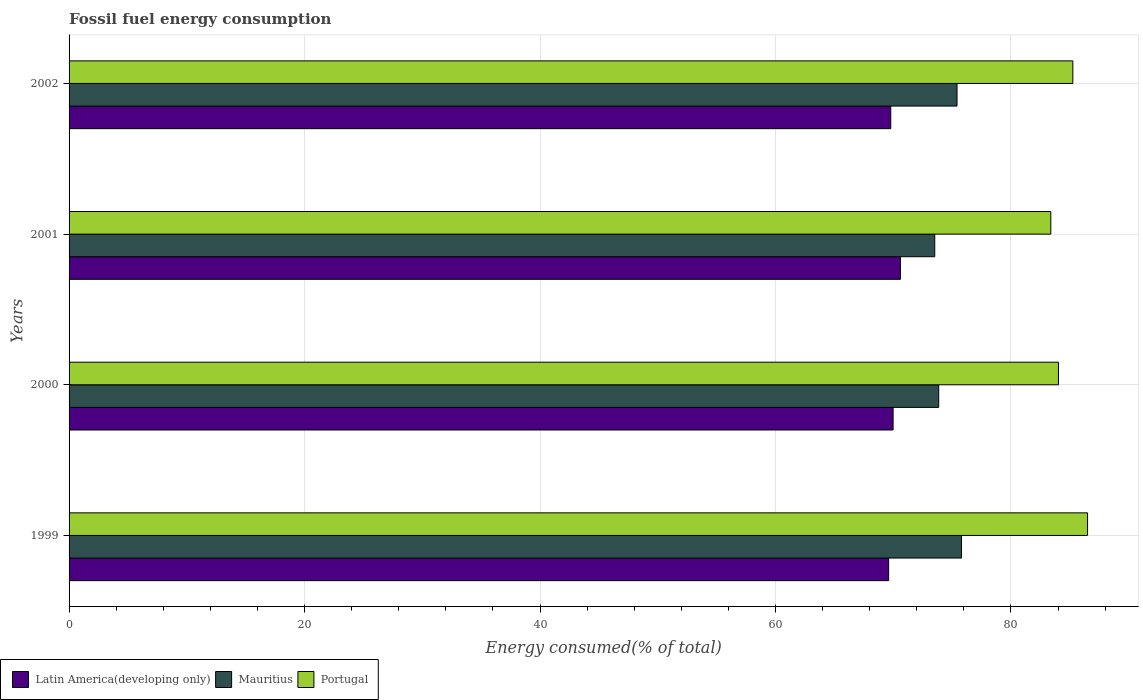How many groups of bars are there?
Your answer should be very brief. 4. Are the number of bars per tick equal to the number of legend labels?
Your response must be concise. Yes. Are the number of bars on each tick of the Y-axis equal?
Offer a very short reply. Yes. What is the label of the 3rd group of bars from the top?
Ensure brevity in your answer.  2000. What is the percentage of energy consumed in Portugal in 2000?
Provide a succinct answer. 84.04. Across all years, what is the maximum percentage of energy consumed in Latin America(developing only)?
Offer a terse response. 70.61. Across all years, what is the minimum percentage of energy consumed in Portugal?
Give a very brief answer. 83.39. What is the total percentage of energy consumed in Portugal in the graph?
Your answer should be very brief. 339.19. What is the difference between the percentage of energy consumed in Portugal in 1999 and that in 2000?
Offer a very short reply. 2.47. What is the difference between the percentage of energy consumed in Latin America(developing only) in 1999 and the percentage of energy consumed in Portugal in 2001?
Offer a very short reply. -13.77. What is the average percentage of energy consumed in Latin America(developing only) per year?
Your answer should be compact. 70. In the year 1999, what is the difference between the percentage of energy consumed in Latin America(developing only) and percentage of energy consumed in Mauritius?
Keep it short and to the point. -6.19. What is the ratio of the percentage of energy consumed in Latin America(developing only) in 2000 to that in 2002?
Provide a succinct answer. 1. Is the percentage of energy consumed in Mauritius in 2001 less than that in 2002?
Keep it short and to the point. Yes. Is the difference between the percentage of energy consumed in Latin America(developing only) in 1999 and 2002 greater than the difference between the percentage of energy consumed in Mauritius in 1999 and 2002?
Make the answer very short. No. What is the difference between the highest and the second highest percentage of energy consumed in Mauritius?
Keep it short and to the point. 0.38. What is the difference between the highest and the lowest percentage of energy consumed in Portugal?
Offer a very short reply. 3.12. Is the sum of the percentage of energy consumed in Mauritius in 1999 and 2001 greater than the maximum percentage of energy consumed in Latin America(developing only) across all years?
Offer a very short reply. Yes. What does the 1st bar from the bottom in 1999 represents?
Your answer should be compact. Latin America(developing only). How many bars are there?
Offer a very short reply. 12. Are all the bars in the graph horizontal?
Offer a very short reply. Yes. How many years are there in the graph?
Provide a succinct answer. 4. Does the graph contain any zero values?
Give a very brief answer. No. Does the graph contain grids?
Your answer should be very brief. Yes. Where does the legend appear in the graph?
Make the answer very short. Bottom left. How are the legend labels stacked?
Ensure brevity in your answer.  Horizontal. What is the title of the graph?
Provide a succinct answer. Fossil fuel energy consumption. Does "Singapore" appear as one of the legend labels in the graph?
Offer a very short reply. No. What is the label or title of the X-axis?
Ensure brevity in your answer.  Energy consumed(% of total). What is the Energy consumed(% of total) of Latin America(developing only) in 1999?
Offer a terse response. 69.61. What is the Energy consumed(% of total) of Mauritius in 1999?
Your answer should be very brief. 75.8. What is the Energy consumed(% of total) of Portugal in 1999?
Make the answer very short. 86.51. What is the Energy consumed(% of total) in Latin America(developing only) in 2000?
Ensure brevity in your answer.  69.99. What is the Energy consumed(% of total) in Mauritius in 2000?
Ensure brevity in your answer.  73.86. What is the Energy consumed(% of total) in Portugal in 2000?
Ensure brevity in your answer.  84.04. What is the Energy consumed(% of total) in Latin America(developing only) in 2001?
Give a very brief answer. 70.61. What is the Energy consumed(% of total) of Mauritius in 2001?
Your answer should be compact. 73.53. What is the Energy consumed(% of total) in Portugal in 2001?
Provide a succinct answer. 83.39. What is the Energy consumed(% of total) in Latin America(developing only) in 2002?
Make the answer very short. 69.79. What is the Energy consumed(% of total) in Mauritius in 2002?
Your answer should be very brief. 75.42. What is the Energy consumed(% of total) in Portugal in 2002?
Make the answer very short. 85.26. Across all years, what is the maximum Energy consumed(% of total) in Latin America(developing only)?
Keep it short and to the point. 70.61. Across all years, what is the maximum Energy consumed(% of total) in Mauritius?
Make the answer very short. 75.8. Across all years, what is the maximum Energy consumed(% of total) in Portugal?
Your answer should be compact. 86.51. Across all years, what is the minimum Energy consumed(% of total) in Latin America(developing only)?
Ensure brevity in your answer.  69.61. Across all years, what is the minimum Energy consumed(% of total) in Mauritius?
Provide a succinct answer. 73.53. Across all years, what is the minimum Energy consumed(% of total) in Portugal?
Your answer should be compact. 83.39. What is the total Energy consumed(% of total) of Latin America(developing only) in the graph?
Offer a terse response. 280. What is the total Energy consumed(% of total) in Mauritius in the graph?
Give a very brief answer. 298.61. What is the total Energy consumed(% of total) of Portugal in the graph?
Give a very brief answer. 339.19. What is the difference between the Energy consumed(% of total) in Latin America(developing only) in 1999 and that in 2000?
Ensure brevity in your answer.  -0.38. What is the difference between the Energy consumed(% of total) of Mauritius in 1999 and that in 2000?
Your answer should be very brief. 1.94. What is the difference between the Energy consumed(% of total) in Portugal in 1999 and that in 2000?
Offer a terse response. 2.47. What is the difference between the Energy consumed(% of total) in Latin America(developing only) in 1999 and that in 2001?
Keep it short and to the point. -1. What is the difference between the Energy consumed(% of total) of Mauritius in 1999 and that in 2001?
Your answer should be compact. 2.27. What is the difference between the Energy consumed(% of total) of Portugal in 1999 and that in 2001?
Provide a succinct answer. 3.12. What is the difference between the Energy consumed(% of total) in Latin America(developing only) in 1999 and that in 2002?
Make the answer very short. -0.18. What is the difference between the Energy consumed(% of total) of Mauritius in 1999 and that in 2002?
Your answer should be very brief. 0.38. What is the difference between the Energy consumed(% of total) in Portugal in 1999 and that in 2002?
Your answer should be very brief. 1.25. What is the difference between the Energy consumed(% of total) of Latin America(developing only) in 2000 and that in 2001?
Your answer should be compact. -0.62. What is the difference between the Energy consumed(% of total) of Mauritius in 2000 and that in 2001?
Provide a short and direct response. 0.34. What is the difference between the Energy consumed(% of total) in Portugal in 2000 and that in 2001?
Your answer should be very brief. 0.65. What is the difference between the Energy consumed(% of total) in Latin America(developing only) in 2000 and that in 2002?
Give a very brief answer. 0.2. What is the difference between the Energy consumed(% of total) in Mauritius in 2000 and that in 2002?
Provide a short and direct response. -1.56. What is the difference between the Energy consumed(% of total) in Portugal in 2000 and that in 2002?
Make the answer very short. -1.22. What is the difference between the Energy consumed(% of total) of Latin America(developing only) in 2001 and that in 2002?
Make the answer very short. 0.82. What is the difference between the Energy consumed(% of total) of Mauritius in 2001 and that in 2002?
Your response must be concise. -1.89. What is the difference between the Energy consumed(% of total) in Portugal in 2001 and that in 2002?
Your response must be concise. -1.87. What is the difference between the Energy consumed(% of total) in Latin America(developing only) in 1999 and the Energy consumed(% of total) in Mauritius in 2000?
Give a very brief answer. -4.25. What is the difference between the Energy consumed(% of total) of Latin America(developing only) in 1999 and the Energy consumed(% of total) of Portugal in 2000?
Offer a very short reply. -14.43. What is the difference between the Energy consumed(% of total) of Mauritius in 1999 and the Energy consumed(% of total) of Portugal in 2000?
Give a very brief answer. -8.23. What is the difference between the Energy consumed(% of total) in Latin America(developing only) in 1999 and the Energy consumed(% of total) in Mauritius in 2001?
Provide a short and direct response. -3.92. What is the difference between the Energy consumed(% of total) in Latin America(developing only) in 1999 and the Energy consumed(% of total) in Portugal in 2001?
Make the answer very short. -13.77. What is the difference between the Energy consumed(% of total) in Mauritius in 1999 and the Energy consumed(% of total) in Portugal in 2001?
Ensure brevity in your answer.  -7.58. What is the difference between the Energy consumed(% of total) of Latin America(developing only) in 1999 and the Energy consumed(% of total) of Mauritius in 2002?
Your response must be concise. -5.81. What is the difference between the Energy consumed(% of total) in Latin America(developing only) in 1999 and the Energy consumed(% of total) in Portugal in 2002?
Keep it short and to the point. -15.65. What is the difference between the Energy consumed(% of total) in Mauritius in 1999 and the Energy consumed(% of total) in Portugal in 2002?
Offer a very short reply. -9.45. What is the difference between the Energy consumed(% of total) in Latin America(developing only) in 2000 and the Energy consumed(% of total) in Mauritius in 2001?
Your response must be concise. -3.54. What is the difference between the Energy consumed(% of total) of Latin America(developing only) in 2000 and the Energy consumed(% of total) of Portugal in 2001?
Make the answer very short. -13.4. What is the difference between the Energy consumed(% of total) in Mauritius in 2000 and the Energy consumed(% of total) in Portugal in 2001?
Provide a succinct answer. -9.52. What is the difference between the Energy consumed(% of total) in Latin America(developing only) in 2000 and the Energy consumed(% of total) in Mauritius in 2002?
Ensure brevity in your answer.  -5.43. What is the difference between the Energy consumed(% of total) of Latin America(developing only) in 2000 and the Energy consumed(% of total) of Portugal in 2002?
Offer a very short reply. -15.27. What is the difference between the Energy consumed(% of total) in Mauritius in 2000 and the Energy consumed(% of total) in Portugal in 2002?
Provide a succinct answer. -11.39. What is the difference between the Energy consumed(% of total) in Latin America(developing only) in 2001 and the Energy consumed(% of total) in Mauritius in 2002?
Your answer should be compact. -4.81. What is the difference between the Energy consumed(% of total) in Latin America(developing only) in 2001 and the Energy consumed(% of total) in Portugal in 2002?
Make the answer very short. -14.64. What is the difference between the Energy consumed(% of total) in Mauritius in 2001 and the Energy consumed(% of total) in Portugal in 2002?
Provide a succinct answer. -11.73. What is the average Energy consumed(% of total) of Latin America(developing only) per year?
Ensure brevity in your answer.  70. What is the average Energy consumed(% of total) of Mauritius per year?
Ensure brevity in your answer.  74.65. What is the average Energy consumed(% of total) in Portugal per year?
Provide a succinct answer. 84.8. In the year 1999, what is the difference between the Energy consumed(% of total) of Latin America(developing only) and Energy consumed(% of total) of Mauritius?
Make the answer very short. -6.19. In the year 1999, what is the difference between the Energy consumed(% of total) of Latin America(developing only) and Energy consumed(% of total) of Portugal?
Provide a short and direct response. -16.9. In the year 1999, what is the difference between the Energy consumed(% of total) in Mauritius and Energy consumed(% of total) in Portugal?
Your answer should be very brief. -10.71. In the year 2000, what is the difference between the Energy consumed(% of total) of Latin America(developing only) and Energy consumed(% of total) of Mauritius?
Your response must be concise. -3.87. In the year 2000, what is the difference between the Energy consumed(% of total) in Latin America(developing only) and Energy consumed(% of total) in Portugal?
Your response must be concise. -14.05. In the year 2000, what is the difference between the Energy consumed(% of total) in Mauritius and Energy consumed(% of total) in Portugal?
Your answer should be very brief. -10.17. In the year 2001, what is the difference between the Energy consumed(% of total) of Latin America(developing only) and Energy consumed(% of total) of Mauritius?
Provide a succinct answer. -2.92. In the year 2001, what is the difference between the Energy consumed(% of total) in Latin America(developing only) and Energy consumed(% of total) in Portugal?
Your response must be concise. -12.77. In the year 2001, what is the difference between the Energy consumed(% of total) in Mauritius and Energy consumed(% of total) in Portugal?
Give a very brief answer. -9.86. In the year 2002, what is the difference between the Energy consumed(% of total) of Latin America(developing only) and Energy consumed(% of total) of Mauritius?
Keep it short and to the point. -5.63. In the year 2002, what is the difference between the Energy consumed(% of total) of Latin America(developing only) and Energy consumed(% of total) of Portugal?
Ensure brevity in your answer.  -15.47. In the year 2002, what is the difference between the Energy consumed(% of total) in Mauritius and Energy consumed(% of total) in Portugal?
Offer a terse response. -9.84. What is the ratio of the Energy consumed(% of total) in Latin America(developing only) in 1999 to that in 2000?
Your answer should be compact. 0.99. What is the ratio of the Energy consumed(% of total) in Mauritius in 1999 to that in 2000?
Keep it short and to the point. 1.03. What is the ratio of the Energy consumed(% of total) in Portugal in 1999 to that in 2000?
Your response must be concise. 1.03. What is the ratio of the Energy consumed(% of total) in Latin America(developing only) in 1999 to that in 2001?
Give a very brief answer. 0.99. What is the ratio of the Energy consumed(% of total) of Mauritius in 1999 to that in 2001?
Your response must be concise. 1.03. What is the ratio of the Energy consumed(% of total) in Portugal in 1999 to that in 2001?
Your answer should be very brief. 1.04. What is the ratio of the Energy consumed(% of total) of Latin America(developing only) in 1999 to that in 2002?
Your answer should be compact. 1. What is the ratio of the Energy consumed(% of total) in Portugal in 1999 to that in 2002?
Provide a succinct answer. 1.01. What is the ratio of the Energy consumed(% of total) of Portugal in 2000 to that in 2001?
Keep it short and to the point. 1.01. What is the ratio of the Energy consumed(% of total) of Mauritius in 2000 to that in 2002?
Offer a terse response. 0.98. What is the ratio of the Energy consumed(% of total) in Portugal in 2000 to that in 2002?
Your answer should be compact. 0.99. What is the ratio of the Energy consumed(% of total) in Latin America(developing only) in 2001 to that in 2002?
Keep it short and to the point. 1.01. What is the ratio of the Energy consumed(% of total) of Mauritius in 2001 to that in 2002?
Offer a terse response. 0.97. What is the ratio of the Energy consumed(% of total) in Portugal in 2001 to that in 2002?
Offer a very short reply. 0.98. What is the difference between the highest and the second highest Energy consumed(% of total) of Latin America(developing only)?
Keep it short and to the point. 0.62. What is the difference between the highest and the second highest Energy consumed(% of total) in Mauritius?
Keep it short and to the point. 0.38. What is the difference between the highest and the second highest Energy consumed(% of total) in Portugal?
Offer a terse response. 1.25. What is the difference between the highest and the lowest Energy consumed(% of total) in Latin America(developing only)?
Ensure brevity in your answer.  1. What is the difference between the highest and the lowest Energy consumed(% of total) in Mauritius?
Your answer should be very brief. 2.27. What is the difference between the highest and the lowest Energy consumed(% of total) in Portugal?
Your answer should be compact. 3.12. 